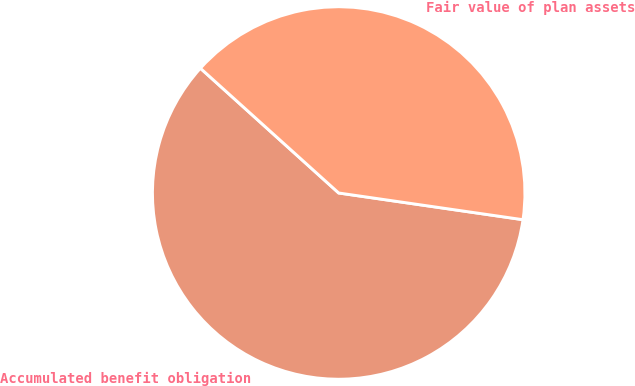<chart> <loc_0><loc_0><loc_500><loc_500><pie_chart><fcel>Accumulated benefit obligation<fcel>Fair value of plan assets<nl><fcel>59.39%<fcel>40.61%<nl></chart> 